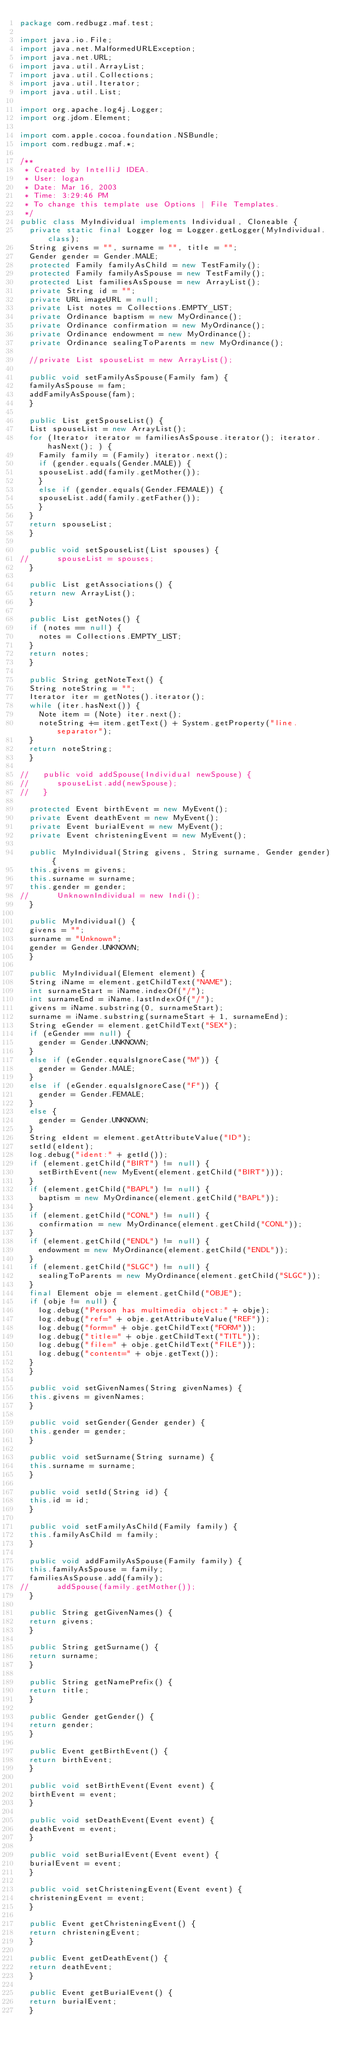<code> <loc_0><loc_0><loc_500><loc_500><_Java_>package com.redbugz.maf.test;

import java.io.File;
import java.net.MalformedURLException;
import java.net.URL;
import java.util.ArrayList;
import java.util.Collections;
import java.util.Iterator;
import java.util.List;

import org.apache.log4j.Logger;
import org.jdom.Element;

import com.apple.cocoa.foundation.NSBundle;
import com.redbugz.maf.*;

/**
 * Created by IntelliJ IDEA.
 * User: logan
 * Date: Mar 16, 2003
 * Time: 3:29:46 PM
 * To change this template use Options | File Templates.
 */
public class MyIndividual implements Individual, Cloneable {
  private static final Logger log = Logger.getLogger(MyIndividual.class);
  String givens = "", surname = "", title = "";
  Gender gender = Gender.MALE;
  protected Family familyAsChild = new TestFamily();
  protected Family familyAsSpouse = new TestFamily();
  protected List familiesAsSpouse = new ArrayList();
  private String id = "";
  private URL imageURL = null;
  private List notes = Collections.EMPTY_LIST;
  private Ordinance baptism = new MyOrdinance();
  private Ordinance confirmation = new MyOrdinance();
  private Ordinance endowment = new MyOrdinance();
  private Ordinance sealingToParents = new MyOrdinance();

  //private List spouseList = new ArrayList();

  public void setFamilyAsSpouse(Family fam) {
	familyAsSpouse = fam;
	addFamilyAsSpouse(fam);
  }

  public List getSpouseList() {
	List spouseList = new ArrayList();
	for (Iterator iterator = familiesAsSpouse.iterator(); iterator.hasNext(); ) {
	  Family family = (Family) iterator.next();
	  if (gender.equals(Gender.MALE)) {
		spouseList.add(family.getMother());
	  }
	  else if (gender.equals(Gender.FEMALE)) {
		spouseList.add(family.getFather());
	  }
	}
	return spouseList;
  }

  public void setSpouseList(List spouses) {
//      spouseList = spouses;
  }

  public List getAssociations() {
	return new ArrayList();
  }

  public List getNotes() {
	if (notes == null) {
	  notes = Collections.EMPTY_LIST;
	}
	return notes;
  }

  public String getNoteText() {
	String noteString = "";
	Iterator iter = getNotes().iterator();
	while (iter.hasNext()) {
	  Note item = (Note) iter.next();
	  noteString += item.getText() + System.getProperty("line.separator");
	}
	return noteString;
  }

//   public void addSpouse(Individual newSpouse) {
//      spouseList.add(newSpouse);
//   }

  protected Event birthEvent = new MyEvent();
  private Event deathEvent = new MyEvent();
  private Event burialEvent = new MyEvent();
  private Event christeningEvent = new MyEvent();

  public MyIndividual(String givens, String surname, Gender gender) {
	this.givens = givens;
	this.surname = surname;
	this.gender = gender;
//      UnknownIndividual = new Indi();
  }

  public MyIndividual() {
	givens = "";
	surname = "Unknown";
	gender = Gender.UNKNOWN;
  }

  public MyIndividual(Element element) {
	String iName = element.getChildText("NAME");
	int surnameStart = iName.indexOf("/");
	int surnameEnd = iName.lastIndexOf("/");
	givens = iName.substring(0, surnameStart);
	surname = iName.substring(surnameStart + 1, surnameEnd);
	String eGender = element.getChildText("SEX");
	if (eGender == null) {
	  gender = Gender.UNKNOWN;
	}
	else if (eGender.equalsIgnoreCase("M")) {
	  gender = Gender.MALE;
	}
	else if (eGender.equalsIgnoreCase("F")) {
	  gender = Gender.FEMALE;
	}
	else {
	  gender = Gender.UNKNOWN;
	}
	String eIdent = element.getAttributeValue("ID");
	setId(eIdent);
	log.debug("ident:" + getId());
	if (element.getChild("BIRT") != null) {
	  setBirthEvent(new MyEvent(element.getChild("BIRT")));
	}
	if (element.getChild("BAPL") != null) {
	  baptism = new MyOrdinance(element.getChild("BAPL"));
	}
	if (element.getChild("CONL") != null) {
	  confirmation = new MyOrdinance(element.getChild("CONL"));
	}
	if (element.getChild("ENDL") != null) {
	  endowment = new MyOrdinance(element.getChild("ENDL"));
	}
	if (element.getChild("SLGC") != null) {
	  sealingToParents = new MyOrdinance(element.getChild("SLGC"));
	}
	final Element obje = element.getChild("OBJE");
	if (obje != null) {
	  log.debug("Person has multimedia object:" + obje);
	  log.debug("ref=" + obje.getAttributeValue("REF"));
	  log.debug("form=" + obje.getChildText("FORM"));
	  log.debug("title=" + obje.getChildText("TITL"));
	  log.debug("file=" + obje.getChildText("FILE"));
	  log.debug("content=" + obje.getText());
	}
  }

  public void setGivenNames(String givenNames) {
	this.givens = givenNames;
  }

  public void setGender(Gender gender) {
	this.gender = gender;
  }

  public void setSurname(String surname) {
	this.surname = surname;
  }

  public void setId(String id) {
	this.id = id;
  }

  public void setFamilyAsChild(Family family) {
	this.familyAsChild = family;
  }

  public void addFamilyAsSpouse(Family family) {
	this.familyAsSpouse = family;
	familiesAsSpouse.add(family);
//      addSpouse(family.getMother());
  }

  public String getGivenNames() {
	return givens;
  }

  public String getSurname() {
	return surname;
  }

  public String getNamePrefix() {
	return title;
  }

  public Gender getGender() {
	return gender;
  }

  public Event getBirthEvent() {
	return birthEvent;
  }

  public void setBirthEvent(Event event) {
	birthEvent = event;
  }

  public void setDeathEvent(Event event) {
	deathEvent = event;
  }

  public void setBurialEvent(Event event) {
	burialEvent = event;
  }

  public void setChristeningEvent(Event event) {
	christeningEvent = event;
  }

  public Event getChristeningEvent() {
	return christeningEvent;
  }

  public Event getDeathEvent() {
	return deathEvent;
  }

  public Event getBurialEvent() {
	return burialEvent;
  }
</code> 